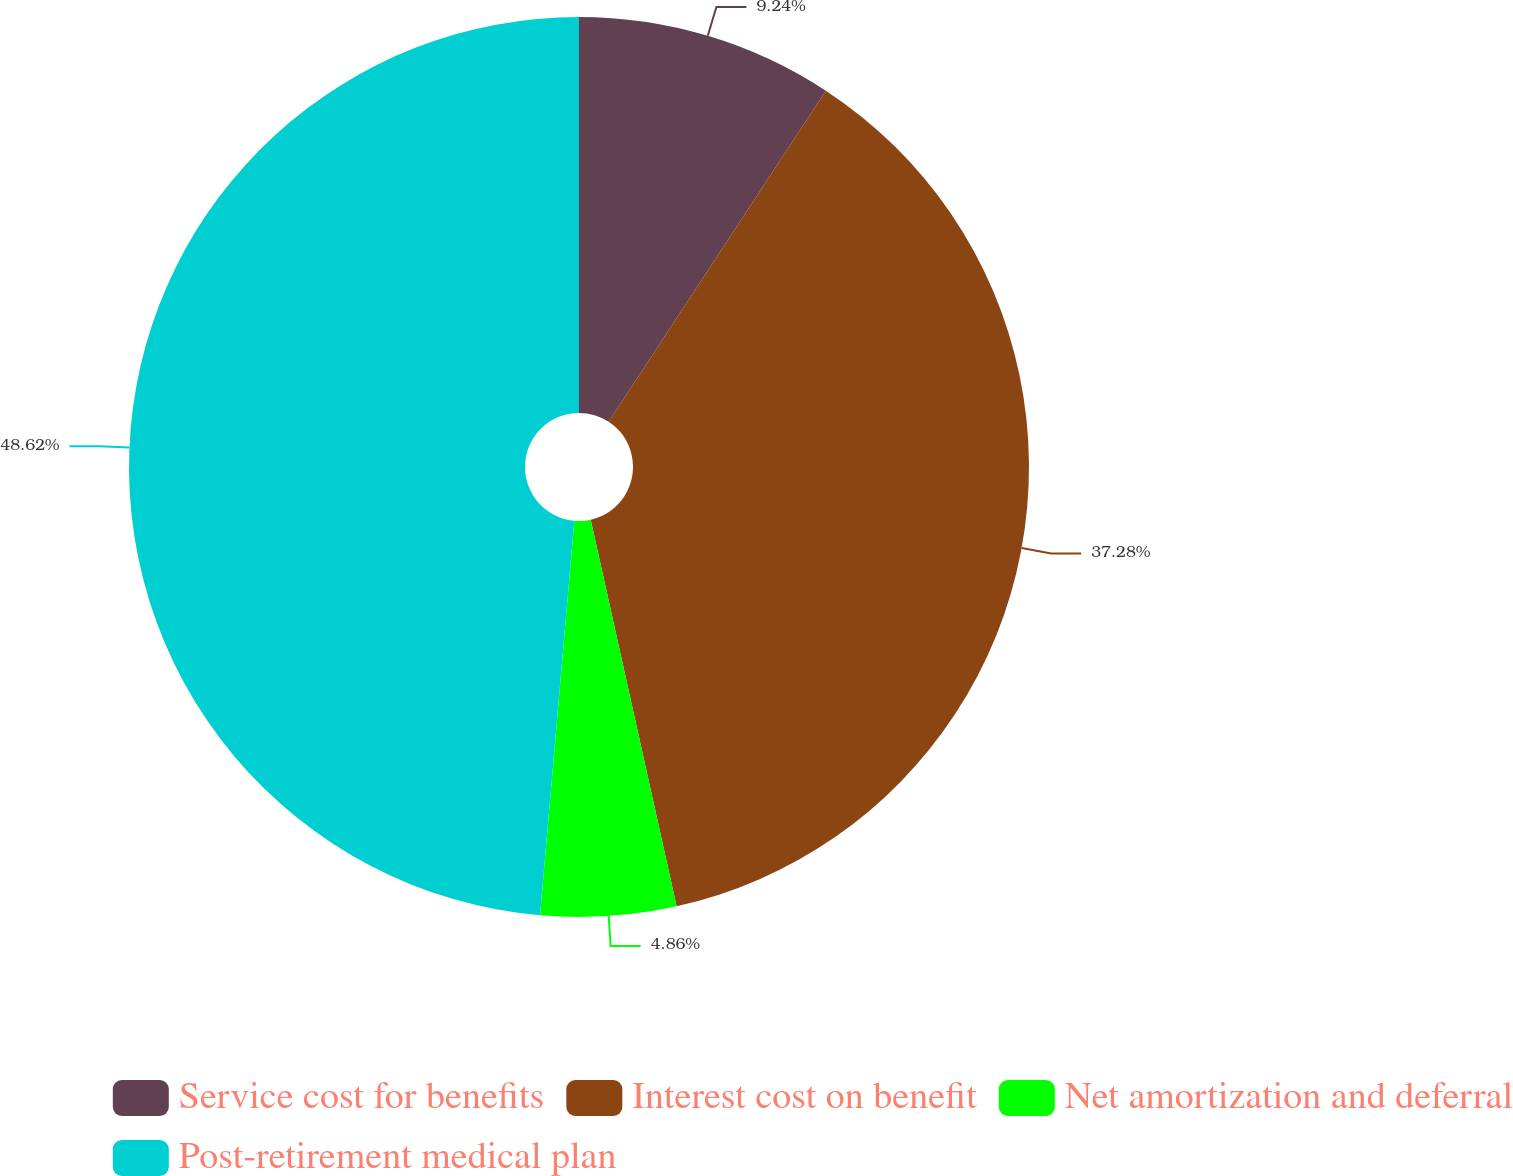<chart> <loc_0><loc_0><loc_500><loc_500><pie_chart><fcel>Service cost for benefits<fcel>Interest cost on benefit<fcel>Net amortization and deferral<fcel>Post-retirement medical plan<nl><fcel>9.24%<fcel>37.28%<fcel>4.86%<fcel>48.62%<nl></chart> 